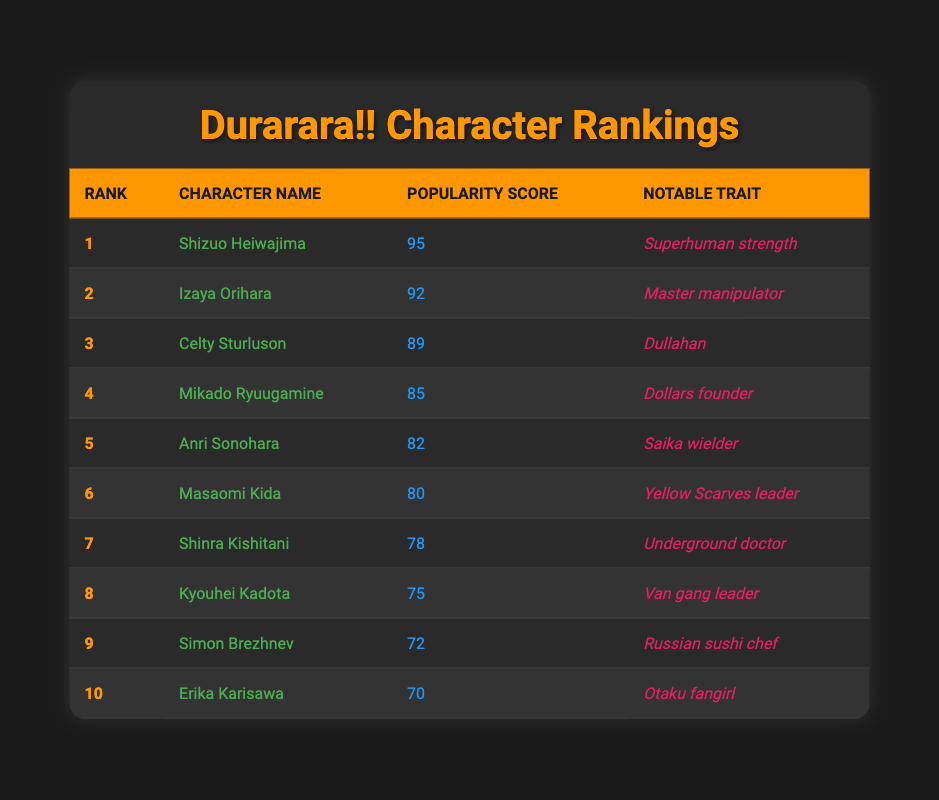What is the popularity score of Shizuo Heiwajima? The table lists Shizuo Heiwajima in Rank 1 with a popularity score of 95.
Answer: 95 Which character has the lowest popularity score? The character with the lowest popularity score in the table is Erika Karisawa with a score of 70, as she is listed last at Rank 10.
Answer: Erika Karisawa Is Anri Sonohara's notable trait related to a weapon? Anri Sonohara is noted as the "Saika wielder," which refers to a weapon she uses, indicating that the trait is weapon-related.
Answer: Yes What is the rank difference between Izaya Orihara and Masaomi Kida? Izaya Orihara is ranked 2nd, while Masaomi Kida is ranked 6th. The rank difference can be calculated as 6 - 2 = 4.
Answer: 4 What is the average popularity score of the top three characters? To find the average, sum the scores of the top three characters: 95 (Shizuo) + 92 (Izaya) + 89 (Celty) = 276. The average is 276 divided by 3, which equals 92.
Answer: 92 How many characters have a popularity score above 80? The characters with scores above 80 are Shizuo (95), Izaya (92), Celty (89), Mikado (85), and Anri (82), which totals 5 characters.
Answer: 5 Does Kyouhei Kadota have a notable trait that implies leadership? Kyouhei Kadota is noted as the "Van gang leader," implying a leadership role in the gang. Therefore, his notable trait does indicate leadership.
Answer: Yes Which character is both a leader and a member of a group? Masaomi Kida is the "Yellow Scarves leader," defining him as a leader, and he is also a member of the Yellow Scarves group. Both conditions are satisfied by him.
Answer: Masaomi Kida What are the popularity scores of the characters ranked 4 and 5 combined? Mikado Ryuugamine is ranked 4th with a score of 85, and Anri Sonohara is ranked 5th with a score of 82. Combined, their scores total 85 + 82 = 167.
Answer: 167 